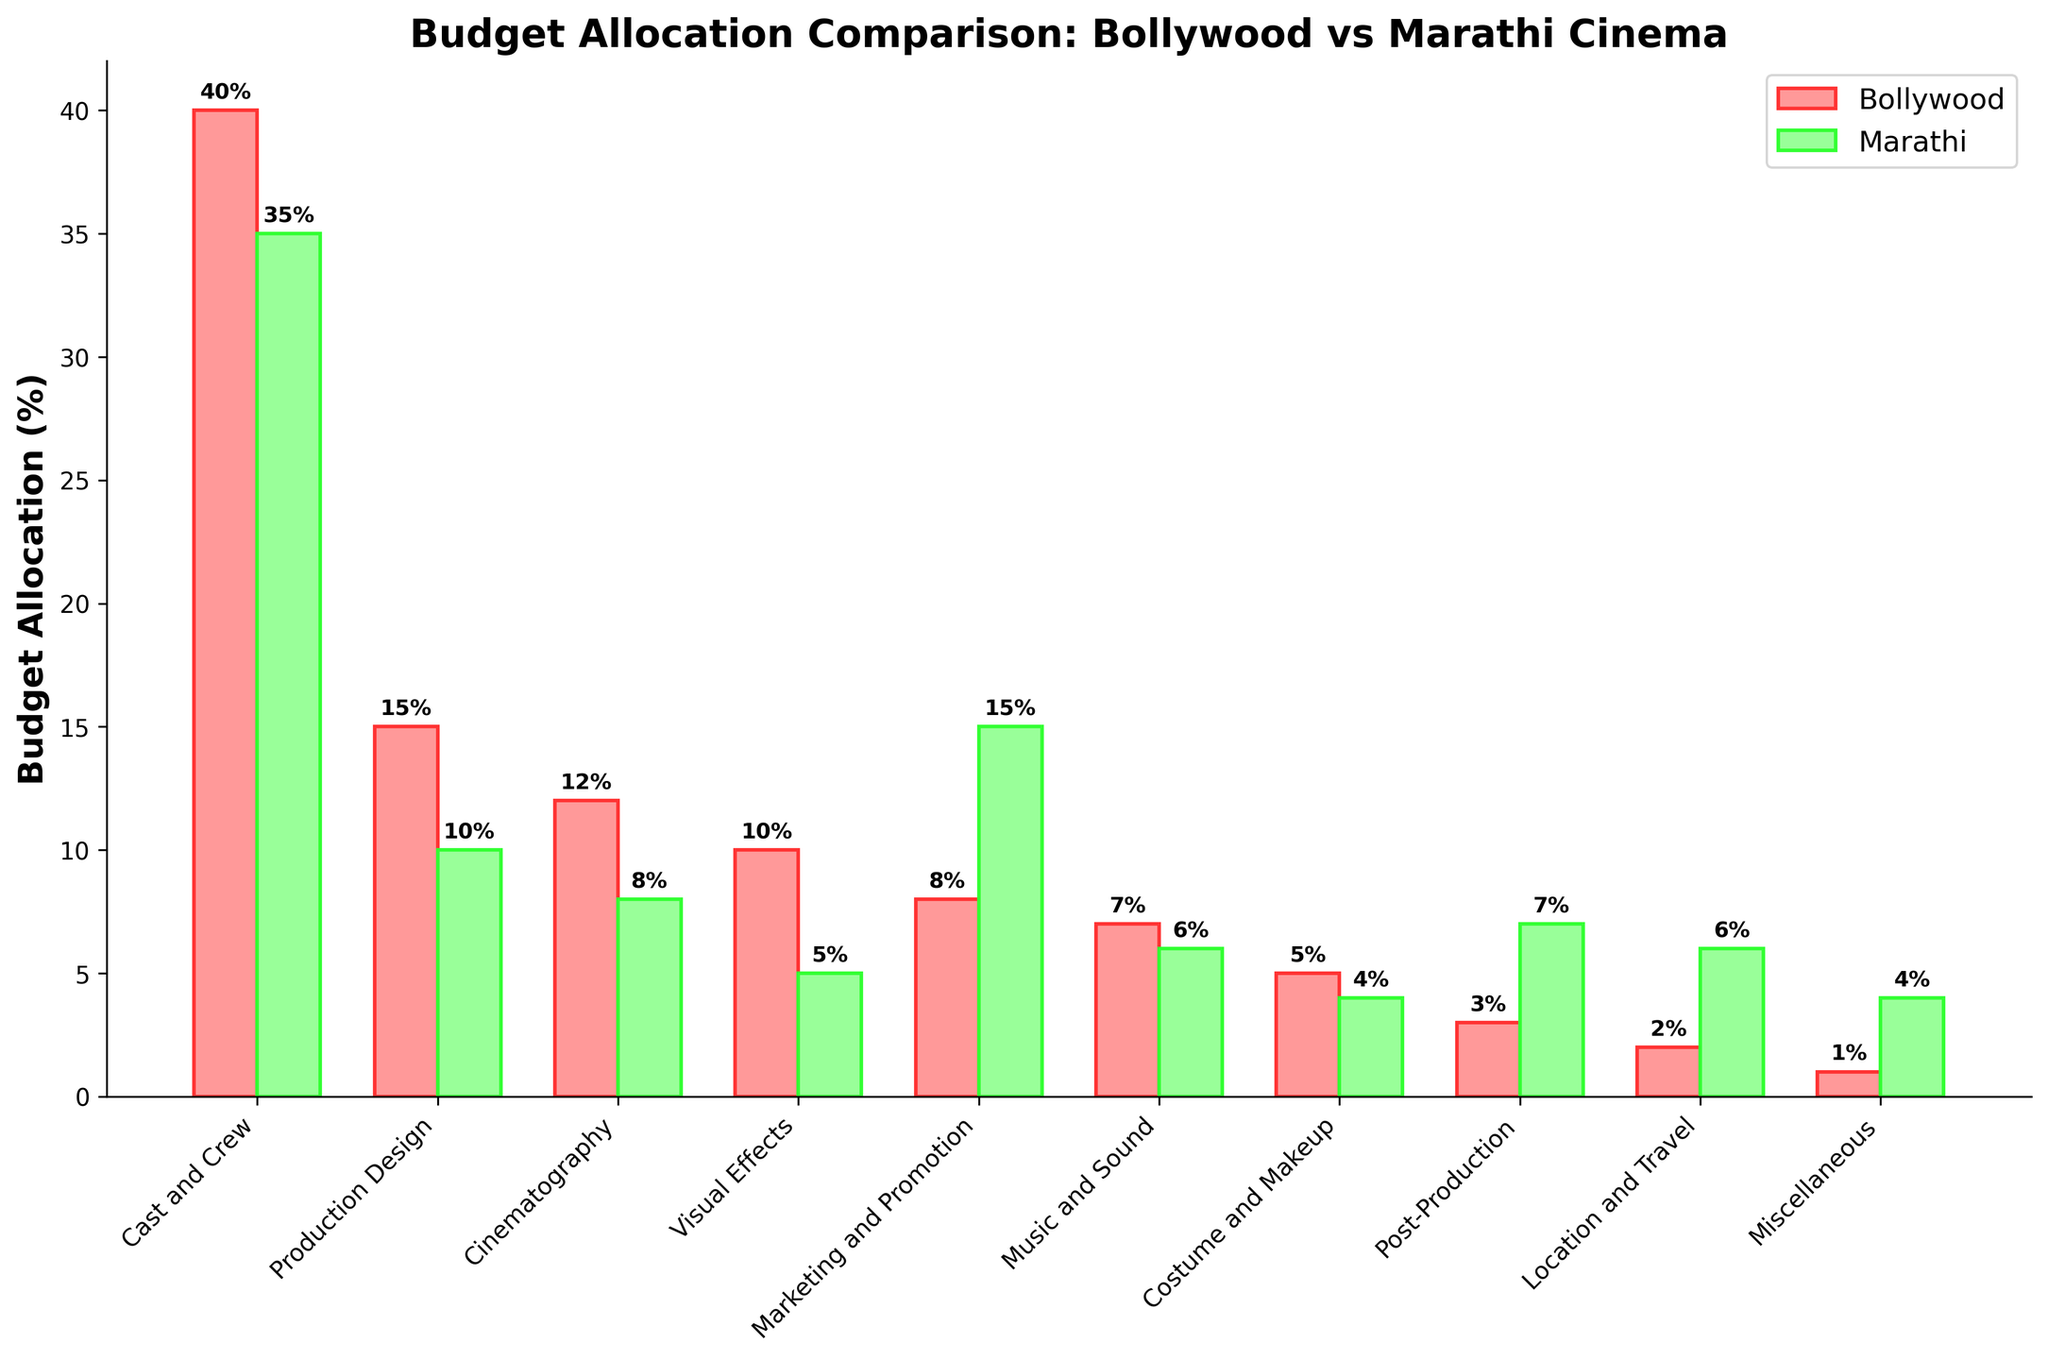Which department has the highest budget allocation in Bollywood films? The department with the highest budget allocation in Bollywood films is the one with the highest bar length for Bollywood in the bar chart. The "Cast and Crew" department has the longest bar for Bollywood.
Answer: Cast and Crew Which department sees a higher budget allocation in Marathi films compared to Bollywood films? By observing each department, notice which has a longer bar for Marathi films than Bollywood films. "Marketing and Promotion" is one such department where the Marathi bar is higher.
Answer: Marketing and Promotion What is the combined budget allocation for Production Design and Visual Effects in Bollywood films? Add the budget percentages for "Production Design" and "Visual Effects" in Bollywood films. That is 15% + 10% = 25%.
Answer: 25% Which department has the smallest budget allocation in Marathi films? Identify the department with the shortest bar in Marathi films in the bar chart. "Miscellaneous" has the shortest bar for Marathi films.
Answer: Miscellaneous What is the difference in budget allocation for Cinematography between Bollywood and Marathi films? Subtract the Marathi budget percentage for "Cinematography" from the Bollywood budget percentage for the same. That is 12% - 8% = 4%.
Answer: 4% In which department is the budget allocation closest between Bollywood and Marathi films? Find the department where the difference in bar lengths between Bollywood and Marathi is the smallest. For "Music and Sound", the budget allocation is 7% in Bollywood and 6% in Marathi, making a difference of 1%.
Answer: Music and Sound What is the total budget allocation for Costume and Makeup, and Post-Production in Marathi films? Add the budget percentages for "Costume and Makeup" and "Post-Production" in Marathi films. That is 4% + 7% = 11%.
Answer: 11% Which department has the highest increase in budget allocation when moving from Marathi to Bollywood films? Identify the department where the Bollywood bar is significantly longer compared to the Marathi bar. "Visual Effects" increases from 5% in Marathi to 10% in Bollywood, the highest among all.
Answer: Visual Effects How much more budget percentage is allocated to Location and Travel in Marathi films than in Bollywood films? Subtract the Bollywood budget percentage for "Location and Travel" from the Marathi budget percentage for the same. 6% - 2% = 4%.
Answer: 4% 